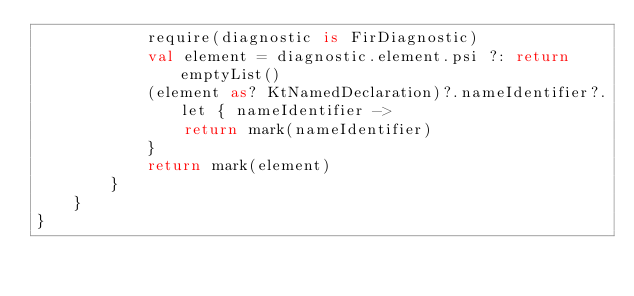Convert code to text. <code><loc_0><loc_0><loc_500><loc_500><_Kotlin_>            require(diagnostic is FirDiagnostic)
            val element = diagnostic.element.psi ?: return emptyList()
            (element as? KtNamedDeclaration)?.nameIdentifier?.let { nameIdentifier ->
                return mark(nameIdentifier)
            }
            return mark(element)
        }
    }
}
</code> 